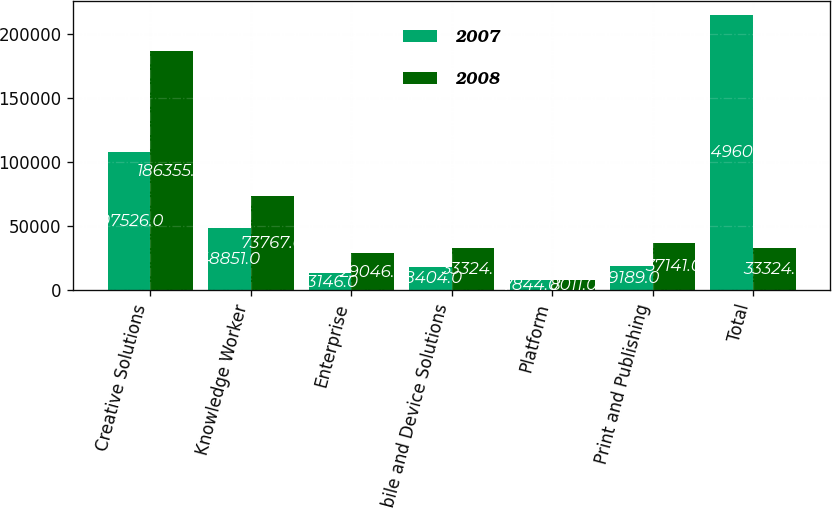<chart> <loc_0><loc_0><loc_500><loc_500><stacked_bar_chart><ecel><fcel>Creative Solutions<fcel>Knowledge Worker<fcel>Enterprise<fcel>Mobile and Device Solutions<fcel>Platform<fcel>Print and Publishing<fcel>Total<nl><fcel>2007<fcel>107526<fcel>48851<fcel>13146<fcel>18404<fcel>7844<fcel>19189<fcel>214960<nl><fcel>2008<fcel>186355<fcel>73767<fcel>29046<fcel>33324<fcel>8011<fcel>37141<fcel>33324<nl></chart> 